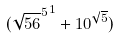<formula> <loc_0><loc_0><loc_500><loc_500>( { \sqrt { 5 6 } ^ { 5 } } ^ { 1 } + 1 0 ^ { \sqrt { 5 } } )</formula> 